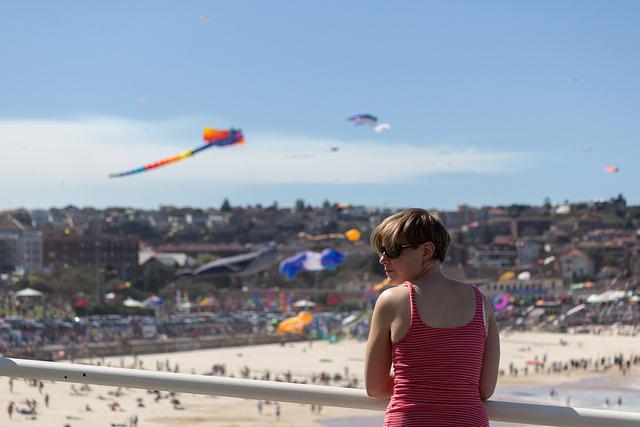What color is her shirt?
Short answer required. Red. Is she up higher than the people on the beach?
Quick response, please. Yes. What is in the air?
Keep it brief. Kites. 